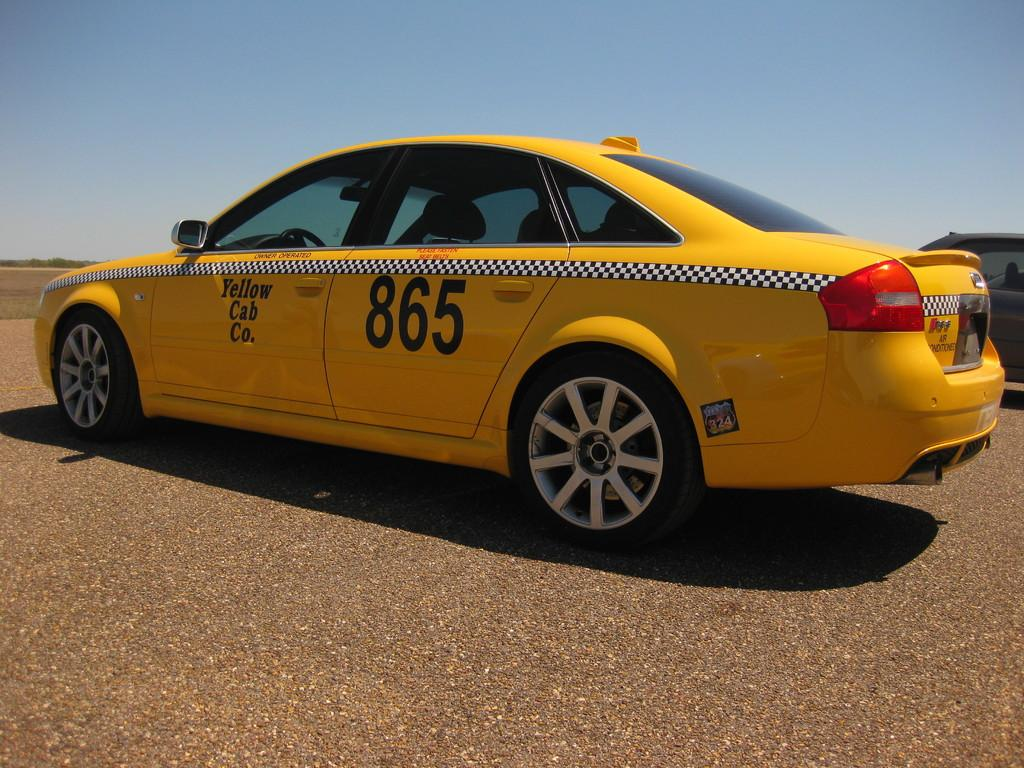<image>
Provide a brief description of the given image. A yellow cab with the number 865 written on one door 